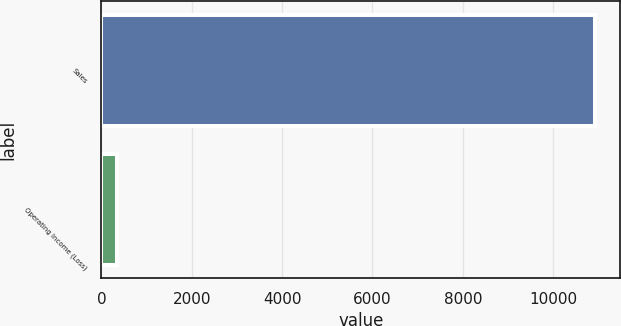Convert chart to OTSL. <chart><loc_0><loc_0><loc_500><loc_500><bar_chart><fcel>Sales<fcel>Operating Income (Loss)<nl><fcel>10937<fcel>346<nl></chart> 